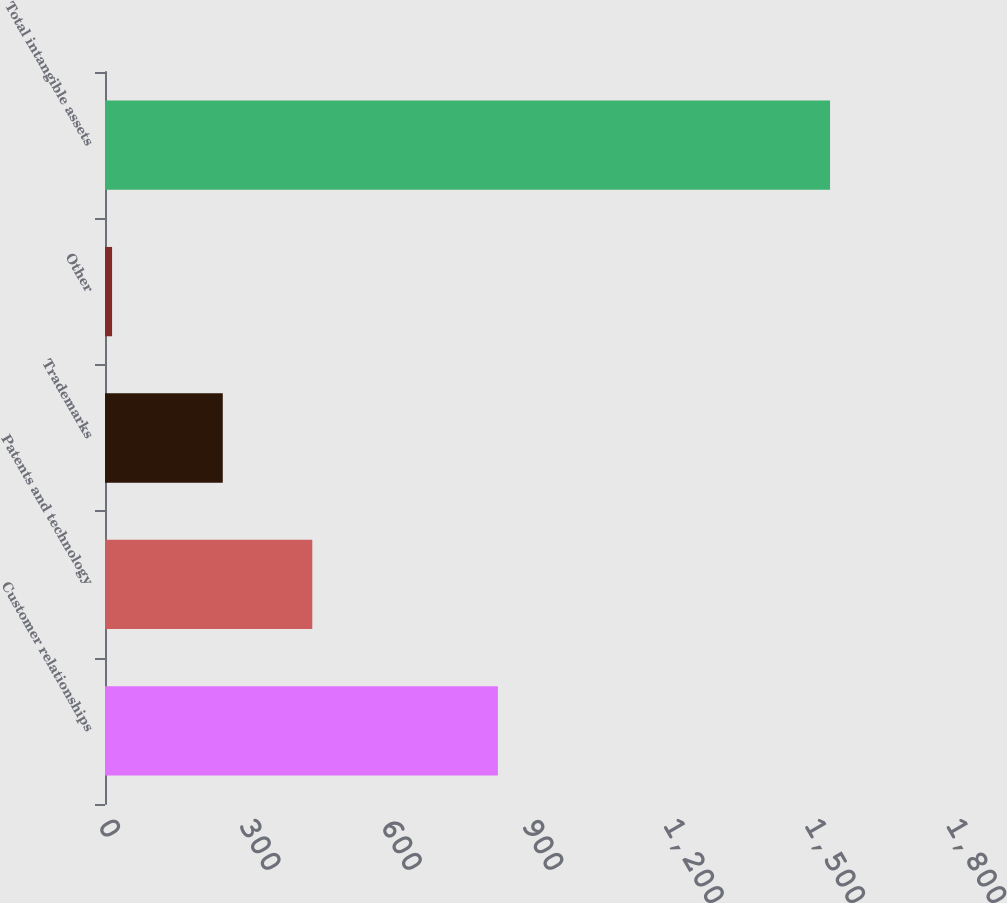Convert chart. <chart><loc_0><loc_0><loc_500><loc_500><bar_chart><fcel>Customer relationships<fcel>Patents and technology<fcel>Trademarks<fcel>Other<fcel>Total intangible assets<nl><fcel>834<fcel>440<fcel>250<fcel>15<fcel>1539<nl></chart> 